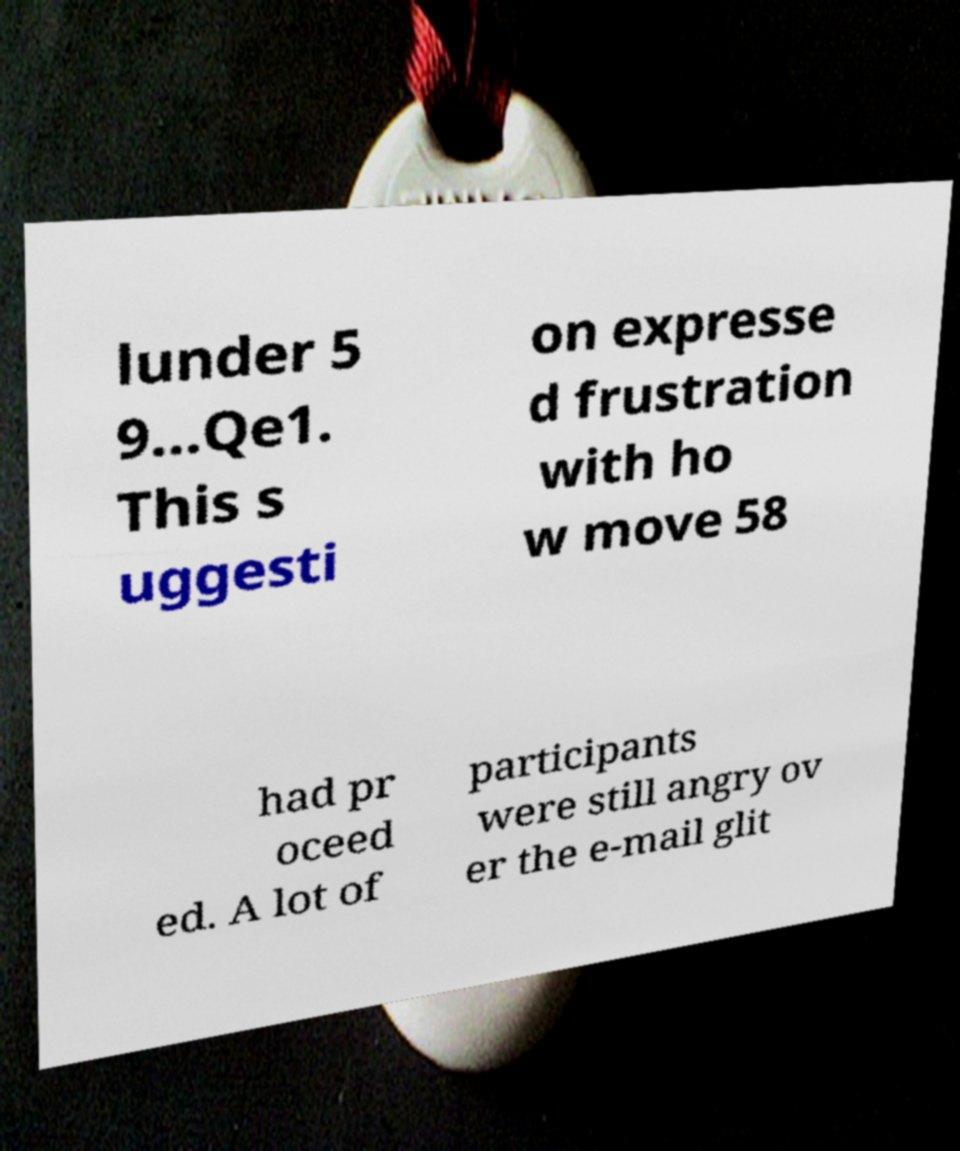Can you read and provide the text displayed in the image?This photo seems to have some interesting text. Can you extract and type it out for me? lunder 5 9...Qe1. This s uggesti on expresse d frustration with ho w move 58 had pr oceed ed. A lot of participants were still angry ov er the e-mail glit 